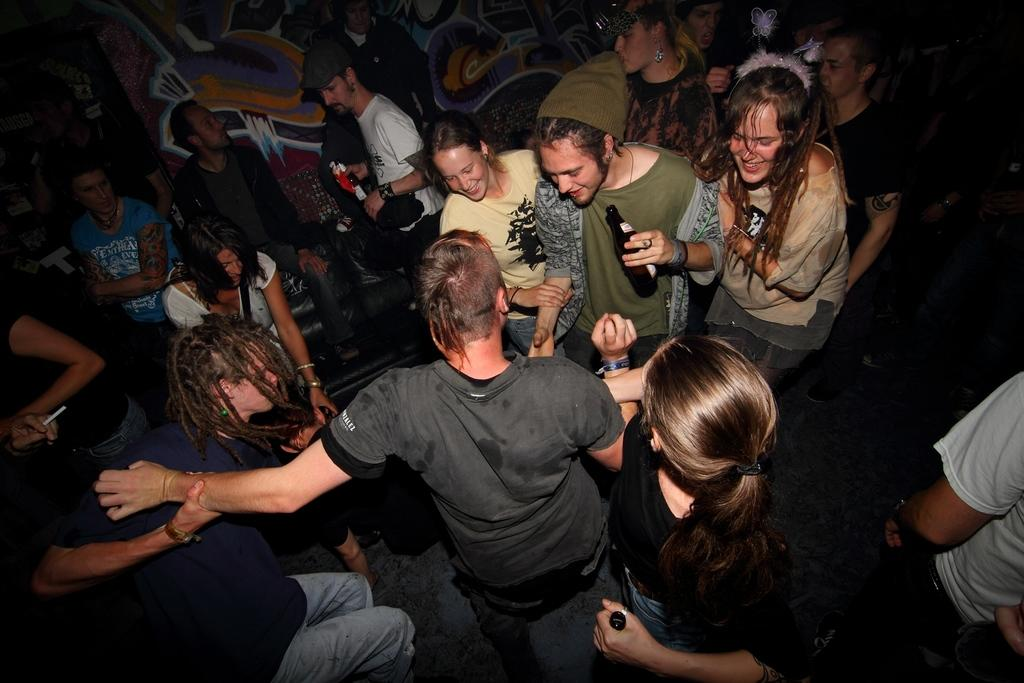How many people are in the image? There are persons in the image, but the exact number is not specified. What are the persons holding in the image? The persons are holding a bottle in the image. What is the surface beneath the persons? There is a floor in the image. What type of furniture is present in the image? There is a sofa in the image. What can be seen in the background of the image? There is a wall in the background of the image. Can you see any rabbits playing on the seashore in the image? There is no seashore or rabbits present in the image. What effect does the bottle have on the persons in the image? The facts provided do not mention any effect the bottle has on the persons. 